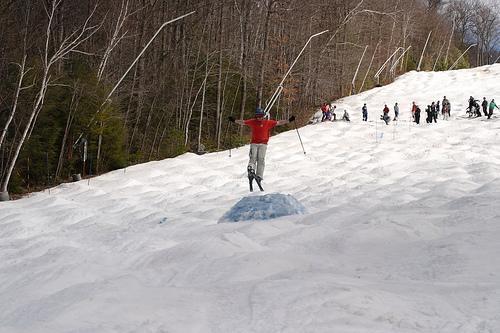How many cats are on the bed?
Give a very brief answer. 0. 